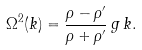<formula> <loc_0><loc_0><loc_500><loc_500>\Omega ^ { 2 } ( k ) = { \frac { \rho - \rho ^ { \prime } } { \rho + \rho ^ { \prime } } } \, g \, k .</formula> 